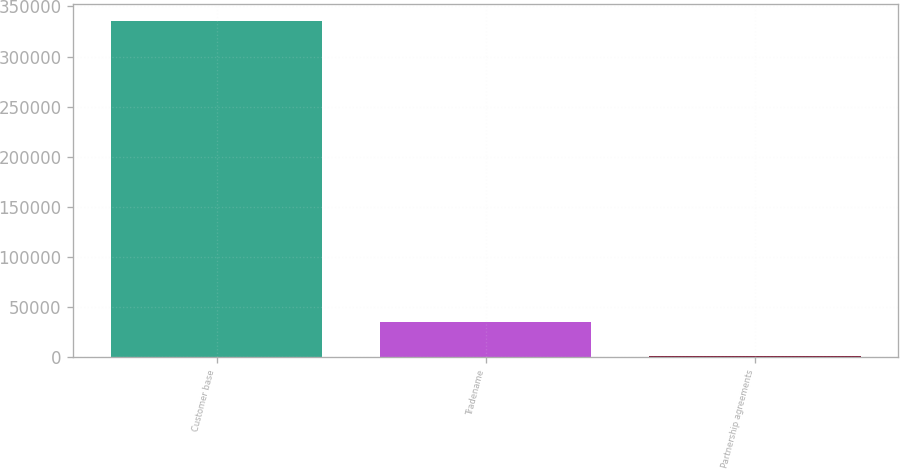<chart> <loc_0><loc_0><loc_500><loc_500><bar_chart><fcel>Customer base<fcel>Tradename<fcel>Partnership agreements<nl><fcel>335393<fcel>34747.1<fcel>1342<nl></chart> 